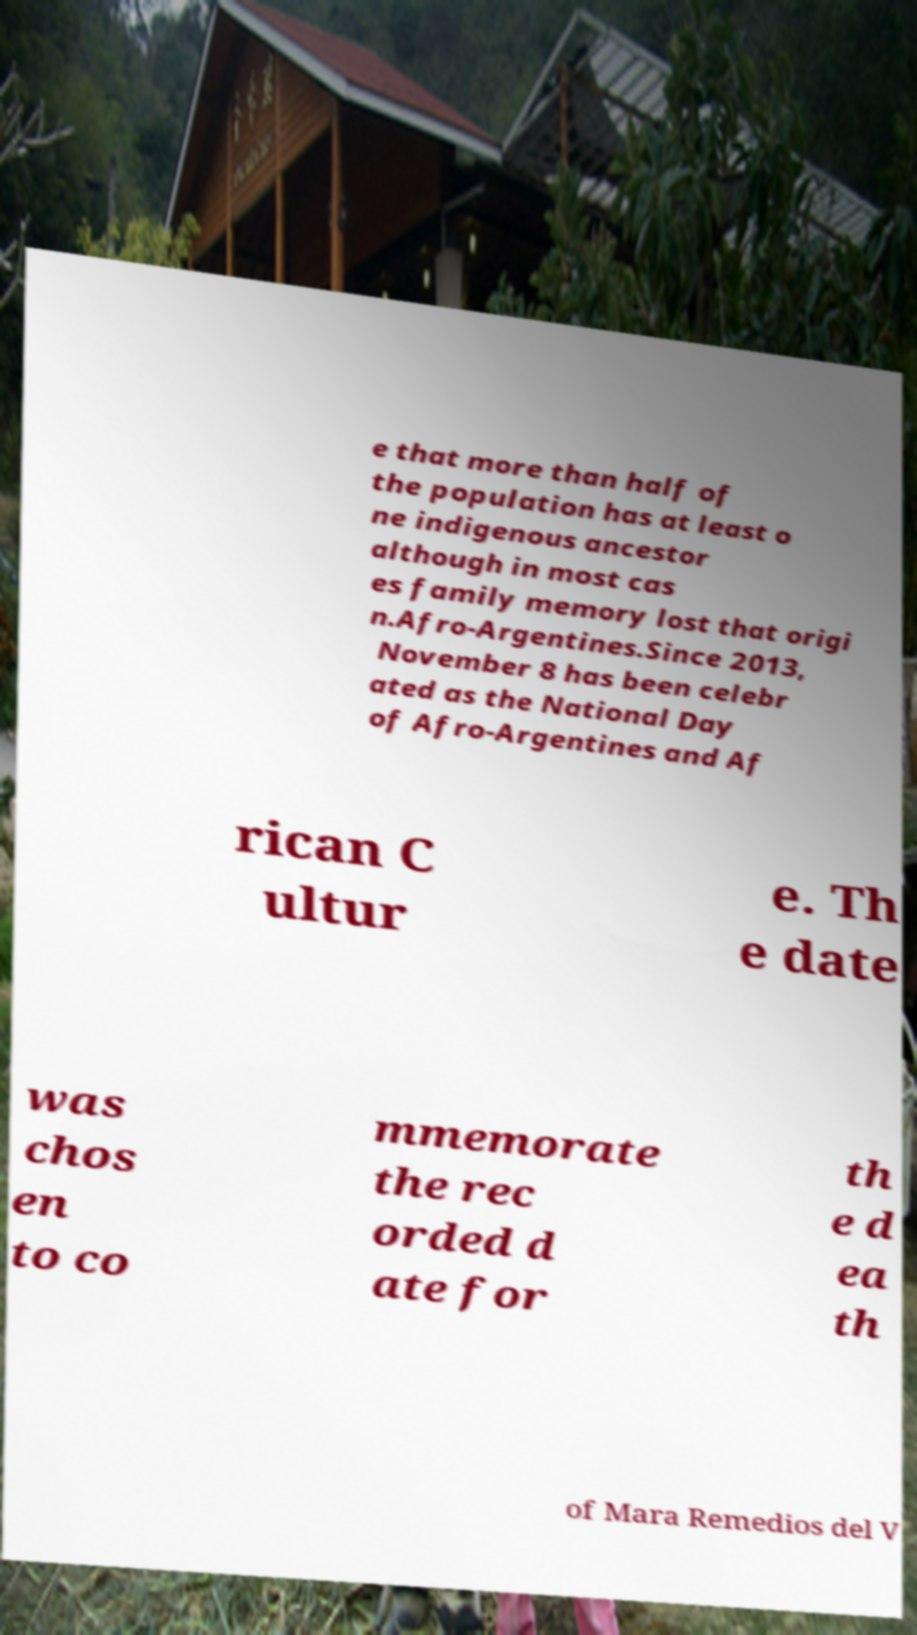I need the written content from this picture converted into text. Can you do that? e that more than half of the population has at least o ne indigenous ancestor although in most cas es family memory lost that origi n.Afro-Argentines.Since 2013, November 8 has been celebr ated as the National Day of Afro-Argentines and Af rican C ultur e. Th e date was chos en to co mmemorate the rec orded d ate for th e d ea th of Mara Remedios del V 